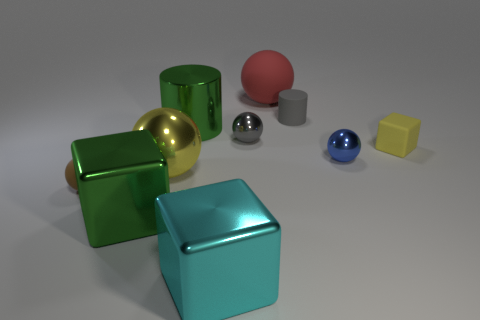There is a cube that is made of the same material as the red sphere; what size is it?
Your response must be concise. Small. There is a green shiny cylinder; is its size the same as the yellow object right of the cyan metal block?
Provide a short and direct response. No. The big thing that is right of the large cylinder and in front of the tiny cylinder is what color?
Make the answer very short. Cyan. What number of things are large yellow shiny spheres that are in front of the tiny gray metallic thing or big metal cubes that are left of the large cyan cube?
Offer a very short reply. 2. What is the color of the tiny metal ball on the right side of the metal ball that is behind the block behind the brown rubber thing?
Keep it short and to the point. Blue. Is there another large metallic thing that has the same shape as the blue metal object?
Make the answer very short. Yes. What number of rubber things are there?
Make the answer very short. 4. What is the shape of the red matte object?
Your response must be concise. Sphere. How many brown metallic blocks have the same size as the gray metallic thing?
Provide a short and direct response. 0. Is the red object the same shape as the tiny gray shiny object?
Ensure brevity in your answer.  Yes. 